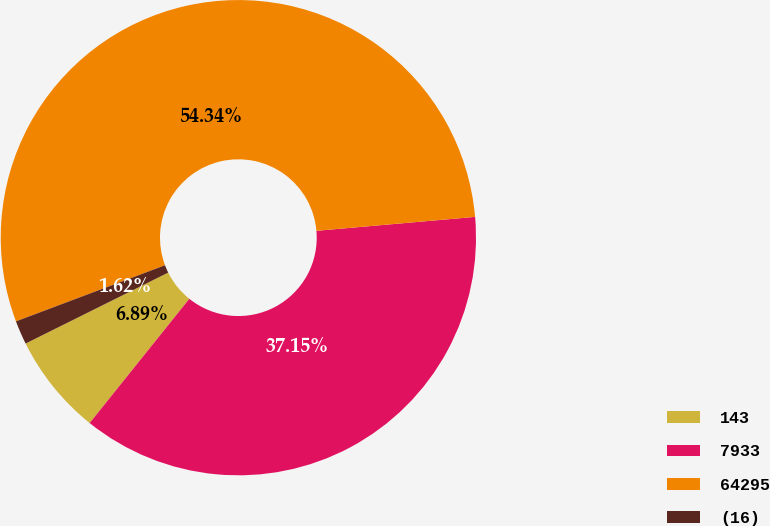Convert chart to OTSL. <chart><loc_0><loc_0><loc_500><loc_500><pie_chart><fcel>143<fcel>7933<fcel>64295<fcel>(16)<nl><fcel>6.89%<fcel>37.15%<fcel>54.33%<fcel>1.62%<nl></chart> 